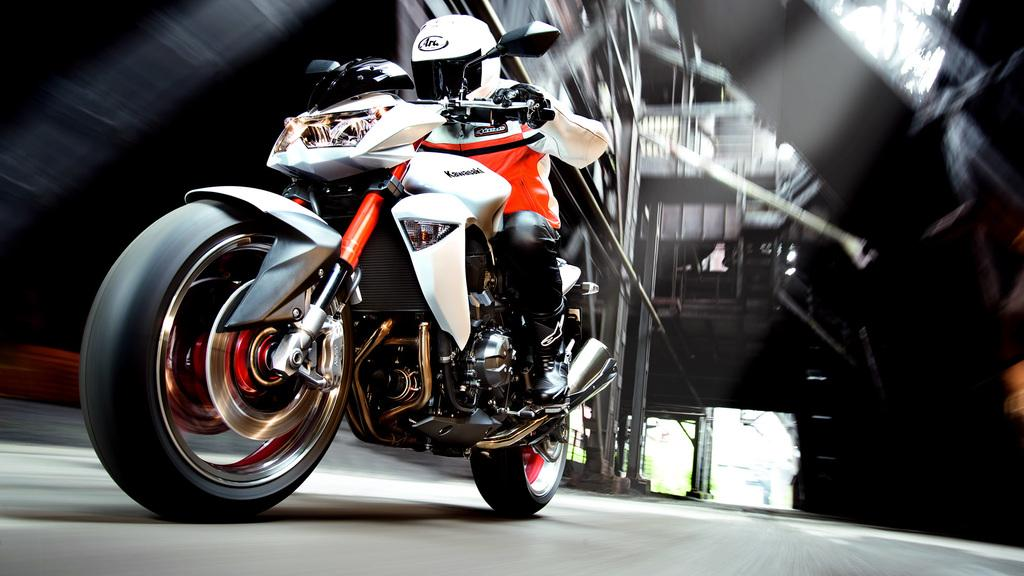What is the main subject of the image? There is a person in the image. What is the person doing in the image? The person is sitting and riding a bike. What safety precaution is the person taking while riding the bike? The person is wearing a helmet. Can you describe the background of the image? The background of the image is blurry. What type of scarecrow can be seen in the image? There is no scarecrow present in the image; it features a person riding a bike. What action is the roll performing in the image? There is no roll present in the image; it features a person riding a bike. 